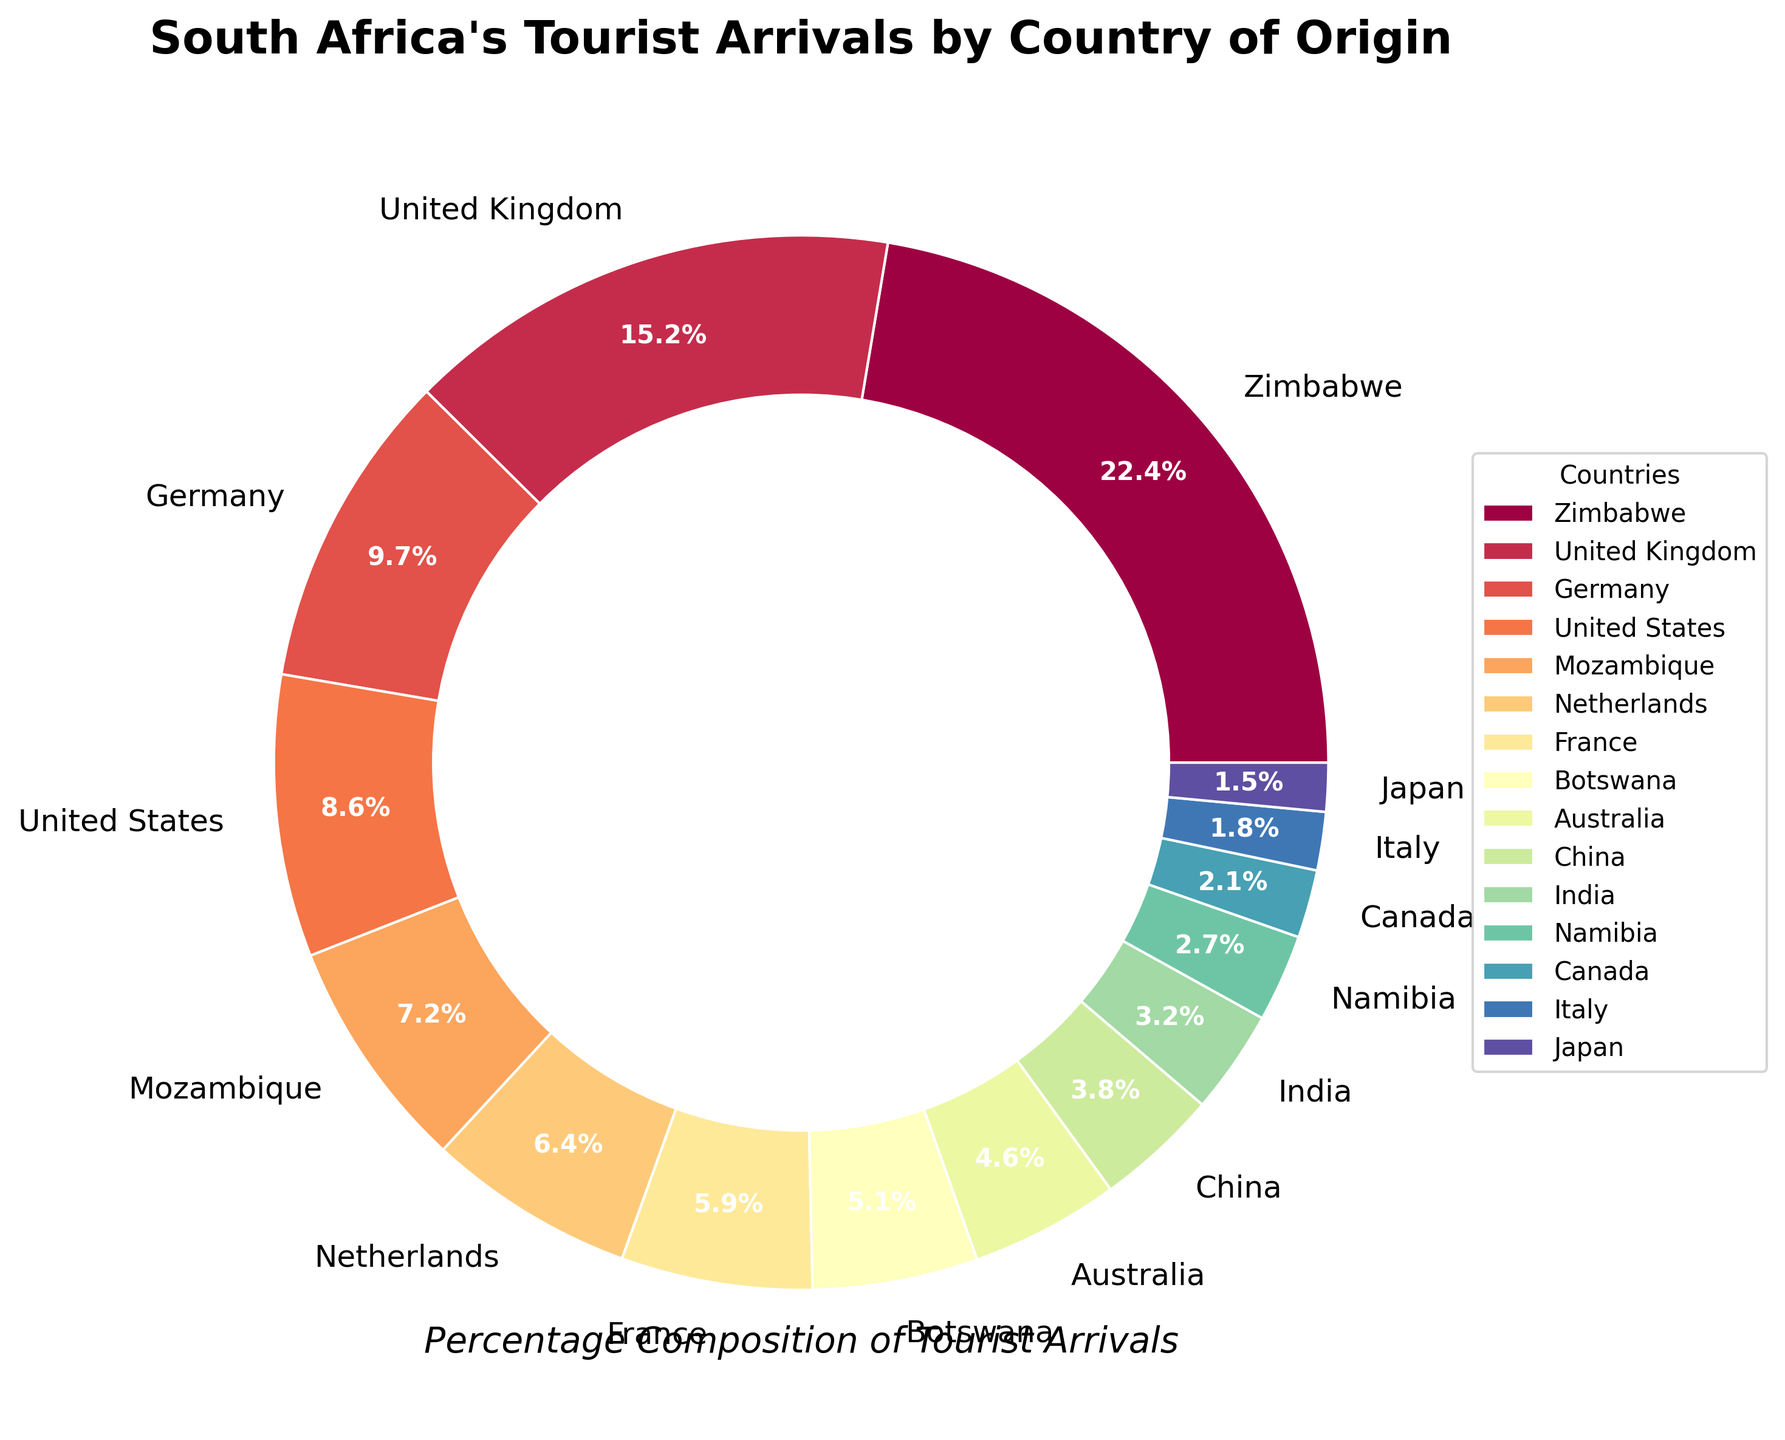Which country contributes the highest percentage of tourist arrivals in South Africa? The pie chart shows the percentage distribution of tourist arrivals by country. Zimbabwe has the largest segment, accounting for 22.5% of tourists.
Answer: Zimbabwe Which country has the smallest percentage of tourist arrivals in South Africa? The pie chart reveals that Japan has the smallest segment, representing 1.5% of the total tourist arrivals.
Answer: Japan What is the combined percentage of tourist arrivals from the United Kingdom, Germany, and the United States? The percentages are 15.3% for the United Kingdom, 9.8% for Germany, and 8.7% for the United States. Summing them up: 15.3 + 9.8 + 8.7 = 33.8%.
Answer: 33.8% How does the percentage of tourist arrivals from Mozambique compare to that from Botswana? Mozambique accounts for 7.2% of tourist arrivals, whereas Botswana accounts for 5.1%. Mozambique has a higher percentage.
Answer: Mozambique has a higher percentage Is the percentage of tourist arrivals from Australia greater than that from China? According to the pie chart, Australia contributes 4.6%, whereas China contributes 3.8%. Australia has a higher percentage.
Answer: Yes Among the countries listed, how many have a percentage contribution of tourist arrivals greater than 5%? The countries with greater than 5% contribution are Zimbabwe (22.5%), United Kingdom (15.3%), Germany (9.8%), United States (8.7%), Mozambique (7.2%), and the Netherlands (6.4%). This adds up to 6 countries.
Answer: 6 What is the visual characteristic (color) used to represent India in the pie chart? Without the figure, we can infer that each country is assigned a unique color along a spectral gradient. However, since the exact color is not described, this cannot be definitively answered from the given data and description.
Answer: Not specified (depends on spectral gradient) How much greater in percentage is the tourist arrival from Zimbabwe compared to that from China? Tourist arrivals from Zimbabwe are 22.5%, and from China are 3.8%. The difference is 22.5 - 3.8 = 18.7%.
Answer: 18.7% What percentage of tourist arrivals do countries other than the top three (Zimbabwe, United Kingdom, Germany) contribute? The total percentage of the top three countries is 22.5 + 15.3 + 9.8 = 47.6%. The other countries together contribute 100% - 47.6% = 52.4%.
Answer: 52.4% 